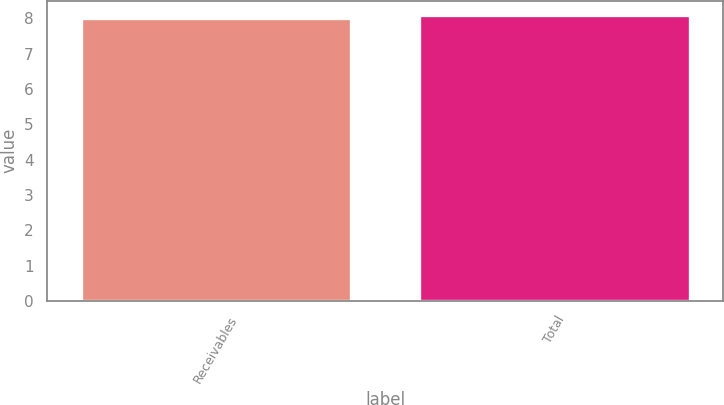Convert chart. <chart><loc_0><loc_0><loc_500><loc_500><bar_chart><fcel>Receivables<fcel>Total<nl><fcel>8<fcel>8.1<nl></chart> 